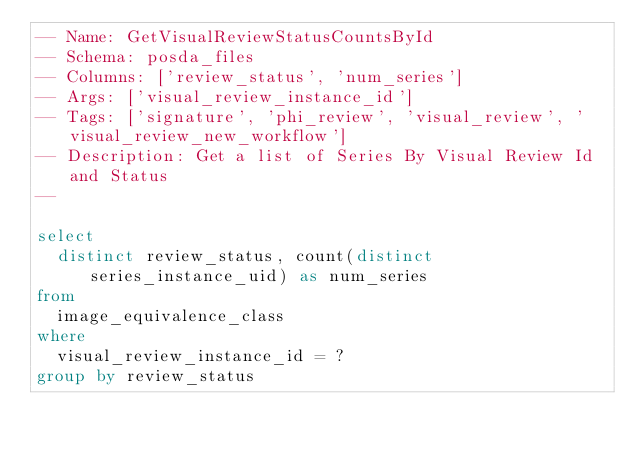<code> <loc_0><loc_0><loc_500><loc_500><_SQL_>-- Name: GetVisualReviewStatusCountsById
-- Schema: posda_files
-- Columns: ['review_status', 'num_series']
-- Args: ['visual_review_instance_id']
-- Tags: ['signature', 'phi_review', 'visual_review', 'visual_review_new_workflow']
-- Description: Get a list of Series By Visual Review Id and Status
-- 

select 
  distinct review_status, count(distinct series_instance_uid) as num_series
from
  image_equivalence_class
where
  visual_review_instance_id = ?
group by review_status</code> 